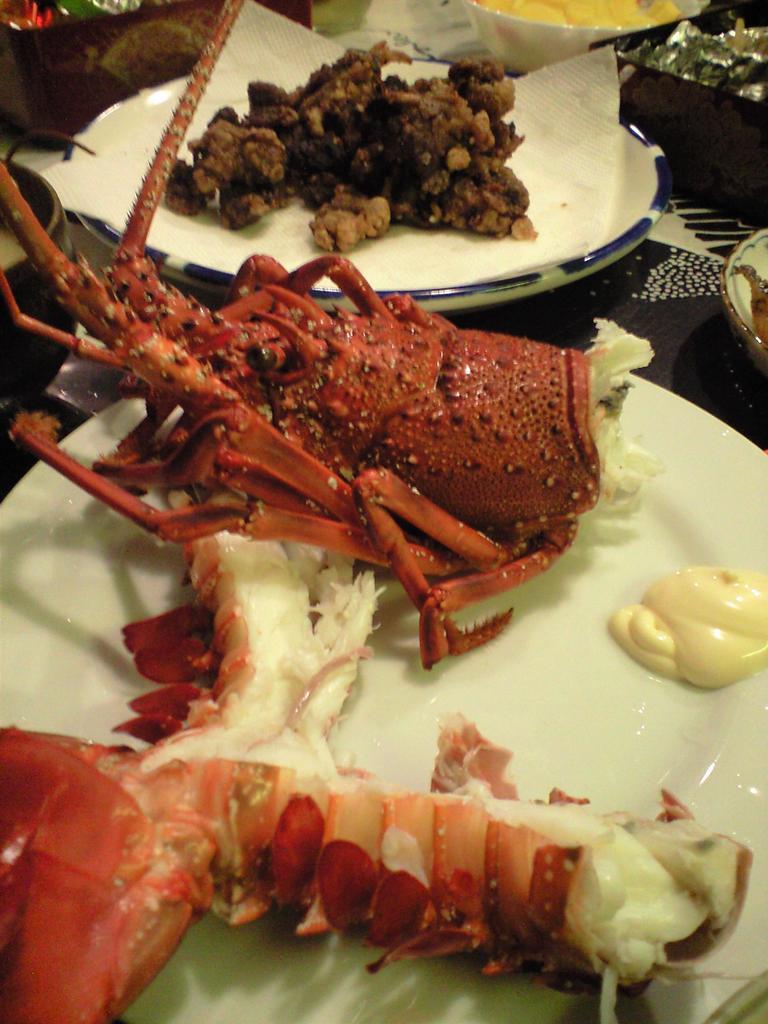Could you give a brief overview of what you see in this image? In the center of the image we can see a lobster, plates, food, napkins, bowls and a box placed on the table. 